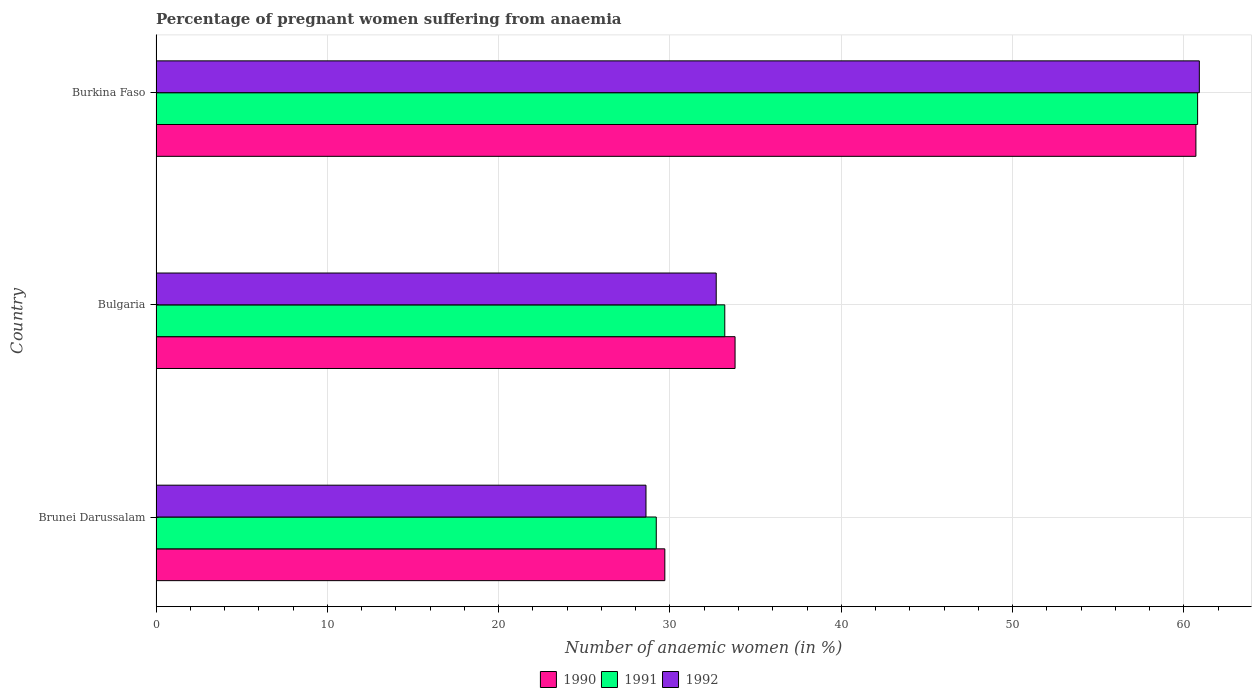How many different coloured bars are there?
Offer a terse response. 3. Are the number of bars per tick equal to the number of legend labels?
Your answer should be compact. Yes. Are the number of bars on each tick of the Y-axis equal?
Offer a terse response. Yes. How many bars are there on the 2nd tick from the top?
Keep it short and to the point. 3. How many bars are there on the 3rd tick from the bottom?
Provide a short and direct response. 3. What is the label of the 1st group of bars from the top?
Provide a short and direct response. Burkina Faso. In how many cases, is the number of bars for a given country not equal to the number of legend labels?
Offer a terse response. 0. What is the number of anaemic women in 1991 in Burkina Faso?
Your response must be concise. 60.8. Across all countries, what is the maximum number of anaemic women in 1990?
Give a very brief answer. 60.7. Across all countries, what is the minimum number of anaemic women in 1990?
Provide a succinct answer. 29.7. In which country was the number of anaemic women in 1990 maximum?
Your response must be concise. Burkina Faso. In which country was the number of anaemic women in 1992 minimum?
Offer a very short reply. Brunei Darussalam. What is the total number of anaemic women in 1991 in the graph?
Offer a very short reply. 123.2. What is the difference between the number of anaemic women in 1990 in Bulgaria and that in Burkina Faso?
Your answer should be compact. -26.9. What is the difference between the number of anaemic women in 1991 in Burkina Faso and the number of anaemic women in 1990 in Brunei Darussalam?
Provide a short and direct response. 31.1. What is the average number of anaemic women in 1990 per country?
Provide a succinct answer. 41.4. What is the difference between the number of anaemic women in 1992 and number of anaemic women in 1990 in Bulgaria?
Provide a succinct answer. -1.1. In how many countries, is the number of anaemic women in 1991 greater than 14 %?
Offer a terse response. 3. What is the ratio of the number of anaemic women in 1992 in Brunei Darussalam to that in Burkina Faso?
Keep it short and to the point. 0.47. What is the difference between the highest and the second highest number of anaemic women in 1990?
Ensure brevity in your answer.  26.9. What is the difference between the highest and the lowest number of anaemic women in 1992?
Offer a very short reply. 32.3. In how many countries, is the number of anaemic women in 1992 greater than the average number of anaemic women in 1992 taken over all countries?
Your answer should be very brief. 1. Is the sum of the number of anaemic women in 1992 in Brunei Darussalam and Bulgaria greater than the maximum number of anaemic women in 1990 across all countries?
Give a very brief answer. Yes. How many bars are there?
Offer a very short reply. 9. How many countries are there in the graph?
Provide a succinct answer. 3. What is the difference between two consecutive major ticks on the X-axis?
Keep it short and to the point. 10. Are the values on the major ticks of X-axis written in scientific E-notation?
Offer a terse response. No. Where does the legend appear in the graph?
Your response must be concise. Bottom center. What is the title of the graph?
Your answer should be compact. Percentage of pregnant women suffering from anaemia. What is the label or title of the X-axis?
Your answer should be compact. Number of anaemic women (in %). What is the label or title of the Y-axis?
Offer a very short reply. Country. What is the Number of anaemic women (in %) of 1990 in Brunei Darussalam?
Offer a very short reply. 29.7. What is the Number of anaemic women (in %) in 1991 in Brunei Darussalam?
Your answer should be very brief. 29.2. What is the Number of anaemic women (in %) in 1992 in Brunei Darussalam?
Provide a succinct answer. 28.6. What is the Number of anaemic women (in %) in 1990 in Bulgaria?
Ensure brevity in your answer.  33.8. What is the Number of anaemic women (in %) in 1991 in Bulgaria?
Provide a short and direct response. 33.2. What is the Number of anaemic women (in %) in 1992 in Bulgaria?
Provide a succinct answer. 32.7. What is the Number of anaemic women (in %) in 1990 in Burkina Faso?
Give a very brief answer. 60.7. What is the Number of anaemic women (in %) in 1991 in Burkina Faso?
Your answer should be very brief. 60.8. What is the Number of anaemic women (in %) in 1992 in Burkina Faso?
Offer a terse response. 60.9. Across all countries, what is the maximum Number of anaemic women (in %) in 1990?
Keep it short and to the point. 60.7. Across all countries, what is the maximum Number of anaemic women (in %) of 1991?
Offer a very short reply. 60.8. Across all countries, what is the maximum Number of anaemic women (in %) of 1992?
Keep it short and to the point. 60.9. Across all countries, what is the minimum Number of anaemic women (in %) in 1990?
Ensure brevity in your answer.  29.7. Across all countries, what is the minimum Number of anaemic women (in %) of 1991?
Your answer should be compact. 29.2. Across all countries, what is the minimum Number of anaemic women (in %) in 1992?
Provide a short and direct response. 28.6. What is the total Number of anaemic women (in %) in 1990 in the graph?
Your answer should be compact. 124.2. What is the total Number of anaemic women (in %) in 1991 in the graph?
Ensure brevity in your answer.  123.2. What is the total Number of anaemic women (in %) of 1992 in the graph?
Provide a succinct answer. 122.2. What is the difference between the Number of anaemic women (in %) in 1991 in Brunei Darussalam and that in Bulgaria?
Ensure brevity in your answer.  -4. What is the difference between the Number of anaemic women (in %) in 1990 in Brunei Darussalam and that in Burkina Faso?
Provide a short and direct response. -31. What is the difference between the Number of anaemic women (in %) of 1991 in Brunei Darussalam and that in Burkina Faso?
Give a very brief answer. -31.6. What is the difference between the Number of anaemic women (in %) of 1992 in Brunei Darussalam and that in Burkina Faso?
Give a very brief answer. -32.3. What is the difference between the Number of anaemic women (in %) in 1990 in Bulgaria and that in Burkina Faso?
Offer a very short reply. -26.9. What is the difference between the Number of anaemic women (in %) of 1991 in Bulgaria and that in Burkina Faso?
Keep it short and to the point. -27.6. What is the difference between the Number of anaemic women (in %) of 1992 in Bulgaria and that in Burkina Faso?
Offer a terse response. -28.2. What is the difference between the Number of anaemic women (in %) in 1990 in Brunei Darussalam and the Number of anaemic women (in %) in 1991 in Burkina Faso?
Offer a very short reply. -31.1. What is the difference between the Number of anaemic women (in %) in 1990 in Brunei Darussalam and the Number of anaemic women (in %) in 1992 in Burkina Faso?
Ensure brevity in your answer.  -31.2. What is the difference between the Number of anaemic women (in %) of 1991 in Brunei Darussalam and the Number of anaemic women (in %) of 1992 in Burkina Faso?
Offer a terse response. -31.7. What is the difference between the Number of anaemic women (in %) in 1990 in Bulgaria and the Number of anaemic women (in %) in 1991 in Burkina Faso?
Your response must be concise. -27. What is the difference between the Number of anaemic women (in %) of 1990 in Bulgaria and the Number of anaemic women (in %) of 1992 in Burkina Faso?
Offer a terse response. -27.1. What is the difference between the Number of anaemic women (in %) of 1991 in Bulgaria and the Number of anaemic women (in %) of 1992 in Burkina Faso?
Offer a terse response. -27.7. What is the average Number of anaemic women (in %) of 1990 per country?
Provide a succinct answer. 41.4. What is the average Number of anaemic women (in %) in 1991 per country?
Offer a very short reply. 41.07. What is the average Number of anaemic women (in %) in 1992 per country?
Provide a succinct answer. 40.73. What is the difference between the Number of anaemic women (in %) of 1990 and Number of anaemic women (in %) of 1991 in Brunei Darussalam?
Make the answer very short. 0.5. What is the difference between the Number of anaemic women (in %) of 1991 and Number of anaemic women (in %) of 1992 in Brunei Darussalam?
Make the answer very short. 0.6. What is the difference between the Number of anaemic women (in %) in 1990 and Number of anaemic women (in %) in 1991 in Bulgaria?
Provide a short and direct response. 0.6. What is the difference between the Number of anaemic women (in %) in 1990 and Number of anaemic women (in %) in 1992 in Bulgaria?
Offer a terse response. 1.1. What is the ratio of the Number of anaemic women (in %) in 1990 in Brunei Darussalam to that in Bulgaria?
Your response must be concise. 0.88. What is the ratio of the Number of anaemic women (in %) in 1991 in Brunei Darussalam to that in Bulgaria?
Provide a short and direct response. 0.88. What is the ratio of the Number of anaemic women (in %) in 1992 in Brunei Darussalam to that in Bulgaria?
Provide a succinct answer. 0.87. What is the ratio of the Number of anaemic women (in %) of 1990 in Brunei Darussalam to that in Burkina Faso?
Keep it short and to the point. 0.49. What is the ratio of the Number of anaemic women (in %) in 1991 in Brunei Darussalam to that in Burkina Faso?
Keep it short and to the point. 0.48. What is the ratio of the Number of anaemic women (in %) in 1992 in Brunei Darussalam to that in Burkina Faso?
Offer a terse response. 0.47. What is the ratio of the Number of anaemic women (in %) of 1990 in Bulgaria to that in Burkina Faso?
Your answer should be very brief. 0.56. What is the ratio of the Number of anaemic women (in %) in 1991 in Bulgaria to that in Burkina Faso?
Offer a terse response. 0.55. What is the ratio of the Number of anaemic women (in %) of 1992 in Bulgaria to that in Burkina Faso?
Ensure brevity in your answer.  0.54. What is the difference between the highest and the second highest Number of anaemic women (in %) in 1990?
Provide a succinct answer. 26.9. What is the difference between the highest and the second highest Number of anaemic women (in %) of 1991?
Your answer should be very brief. 27.6. What is the difference between the highest and the second highest Number of anaemic women (in %) of 1992?
Provide a short and direct response. 28.2. What is the difference between the highest and the lowest Number of anaemic women (in %) of 1990?
Keep it short and to the point. 31. What is the difference between the highest and the lowest Number of anaemic women (in %) of 1991?
Ensure brevity in your answer.  31.6. What is the difference between the highest and the lowest Number of anaemic women (in %) of 1992?
Keep it short and to the point. 32.3. 